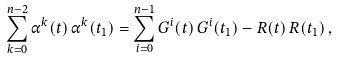<formula> <loc_0><loc_0><loc_500><loc_500>\sum _ { k = 0 } ^ { n - 2 } \alpha ^ { k } ( t ) \, \alpha ^ { k } ( t _ { 1 } ) = \sum _ { i = 0 } ^ { n - 1 } G ^ { i } ( t ) \, G ^ { i } ( t _ { 1 } ) - R ( t ) \, R ( t _ { 1 } ) \, ,</formula> 